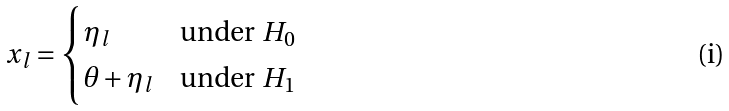<formula> <loc_0><loc_0><loc_500><loc_500>x _ { l } = \begin{cases} \eta _ { l } & \text {under $H_{0}$} \\ \theta + \eta _ { l } & \text {under $H_{1}$} \end{cases}</formula> 